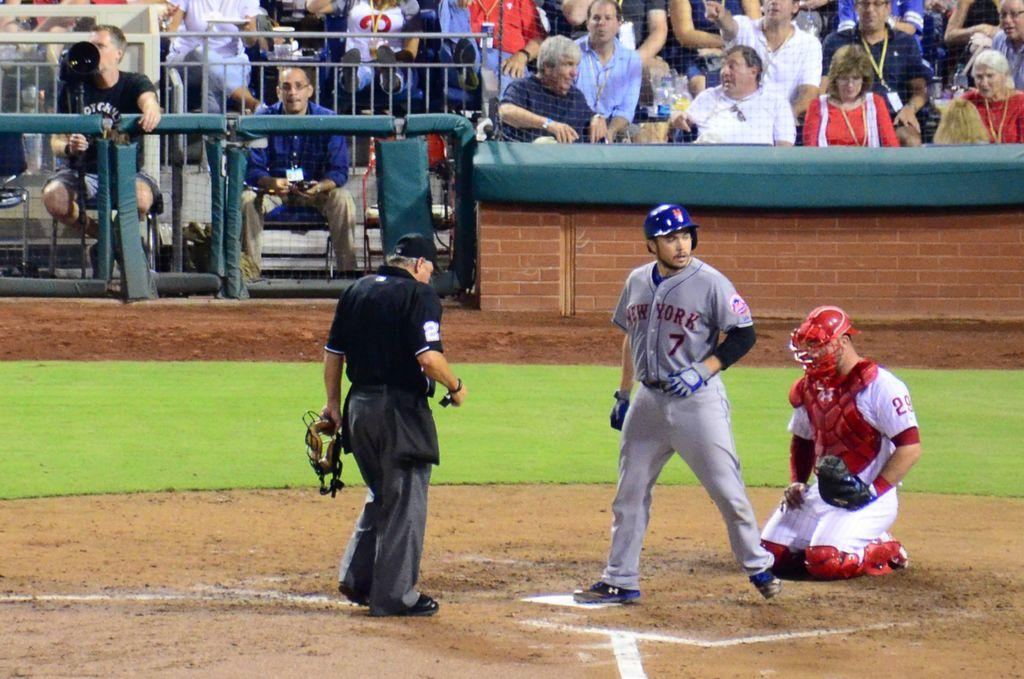<image>
Summarize the visual content of the image. New York Mets baseball player #7 looking into left field from home plate. 